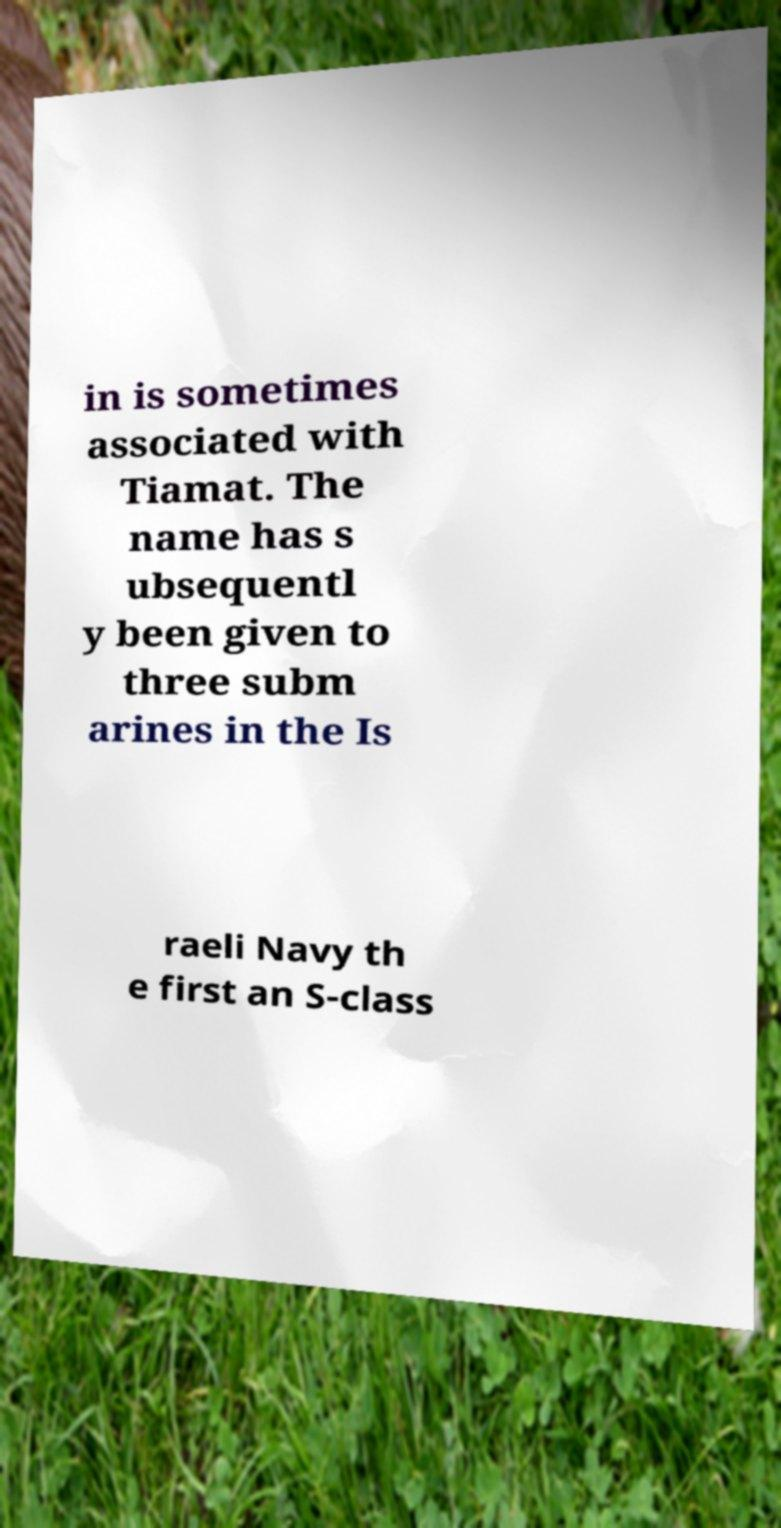Could you extract and type out the text from this image? in is sometimes associated with Tiamat. The name has s ubsequentl y been given to three subm arines in the Is raeli Navy th e first an S-class 